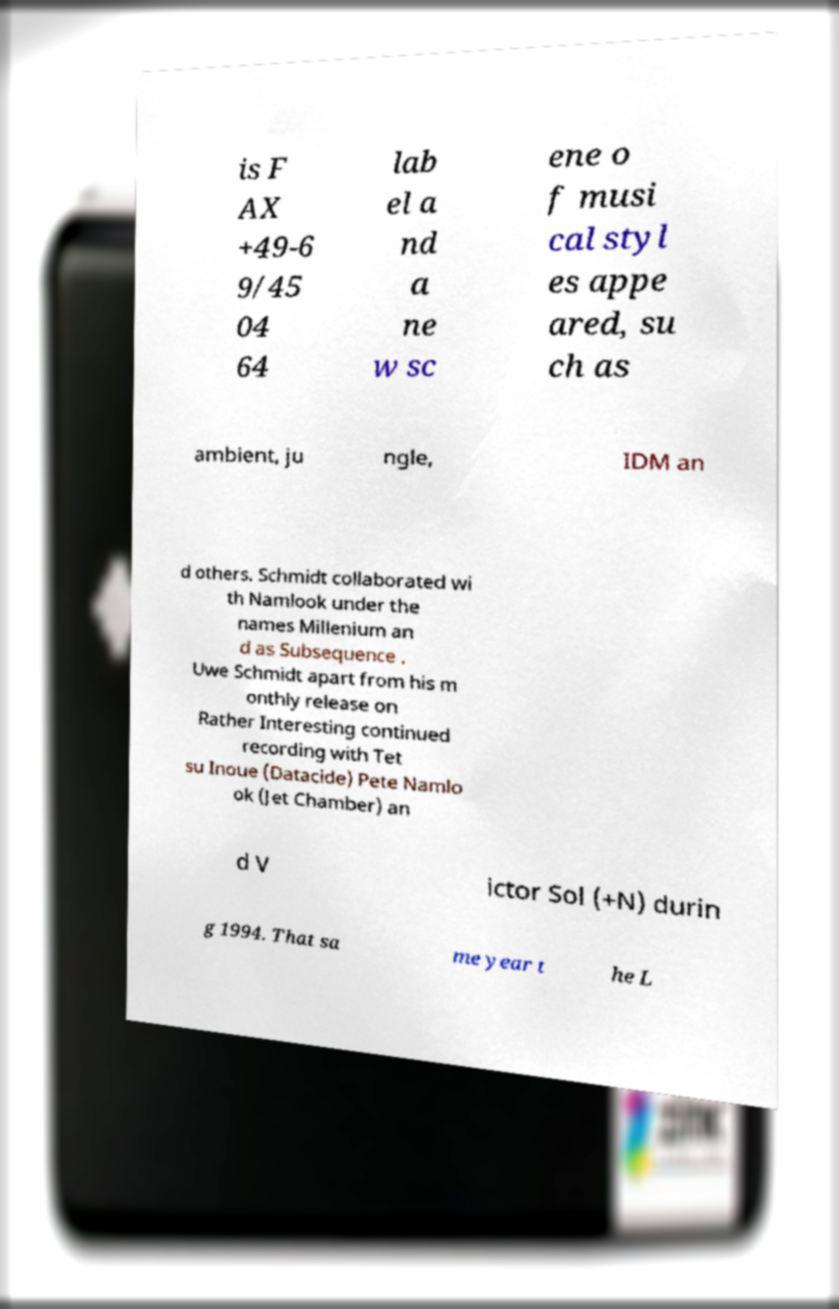Can you accurately transcribe the text from the provided image for me? is F AX +49-6 9/45 04 64 lab el a nd a ne w sc ene o f musi cal styl es appe ared, su ch as ambient, ju ngle, IDM an d others. Schmidt collaborated wi th Namlook under the names Millenium an d as Subsequence . Uwe Schmidt apart from his m onthly release on Rather Interesting continued recording with Tet su Inoue (Datacide) Pete Namlo ok (Jet Chamber) an d V ictor Sol (+N) durin g 1994. That sa me year t he L 